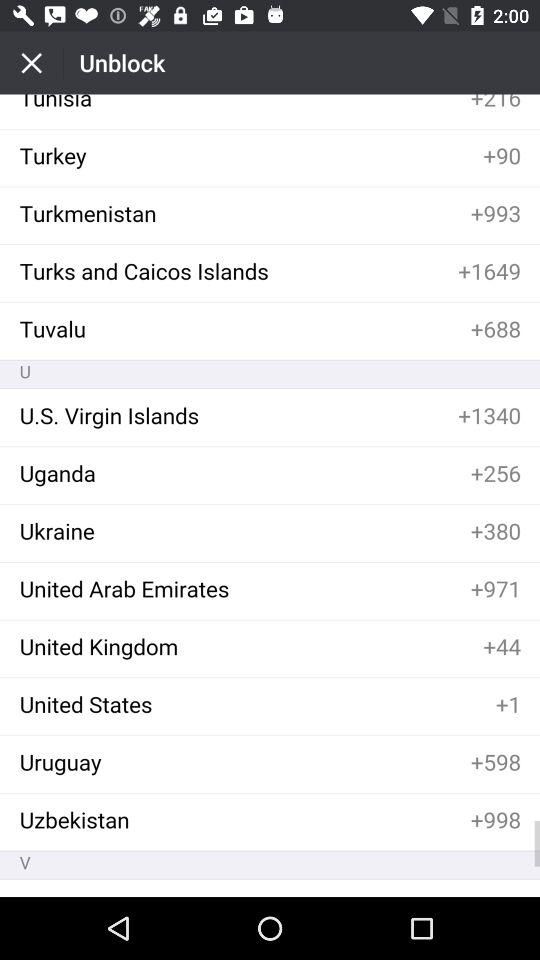What is Tuvalu's country code? Tuvalu's country code is +688. 